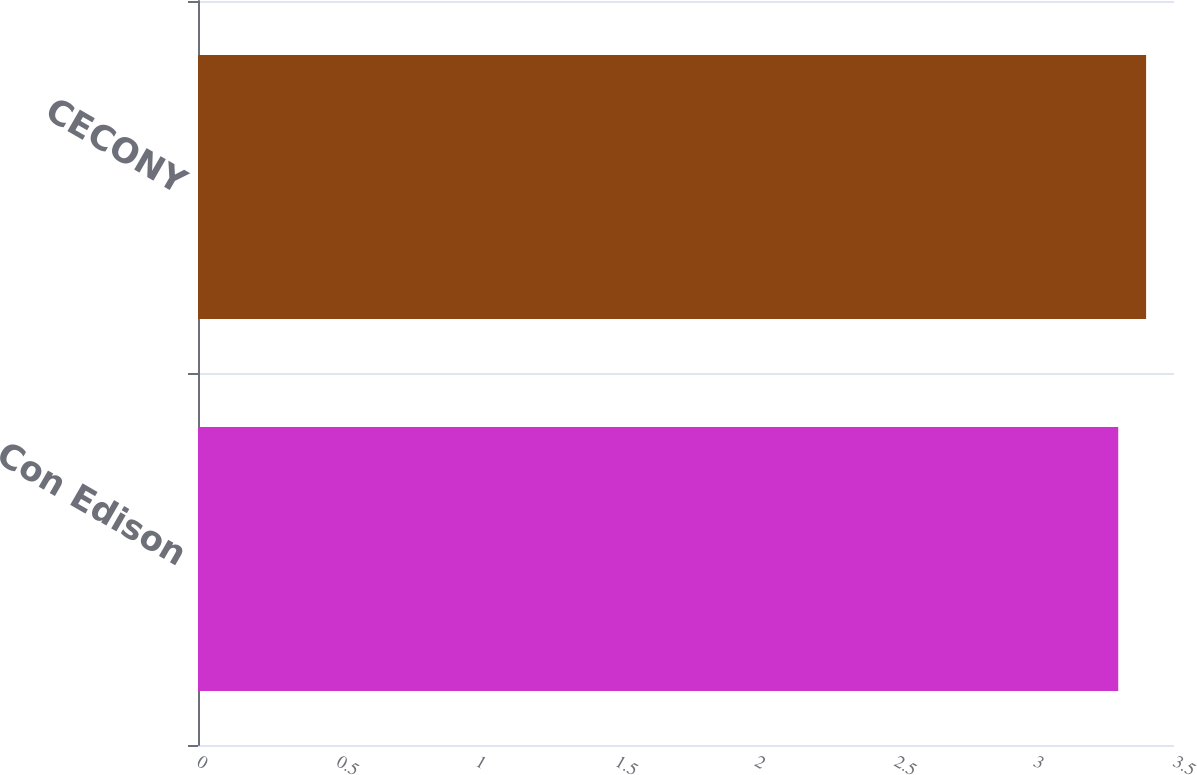Convert chart to OTSL. <chart><loc_0><loc_0><loc_500><loc_500><bar_chart><fcel>Con Edison<fcel>CECONY<nl><fcel>3.3<fcel>3.4<nl></chart> 